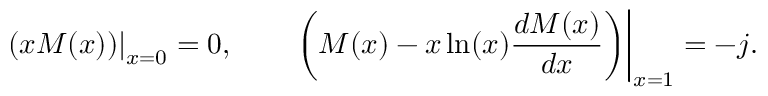<formula> <loc_0><loc_0><loc_500><loc_500>\left ( x M ( x ) \right ) \right | _ { x = 0 } = 0 , \quad \left ( M ( x ) - x \ln ( x ) \frac { d M ( x ) } { d x } \right ) \right | _ { x = 1 } = - j .</formula> 